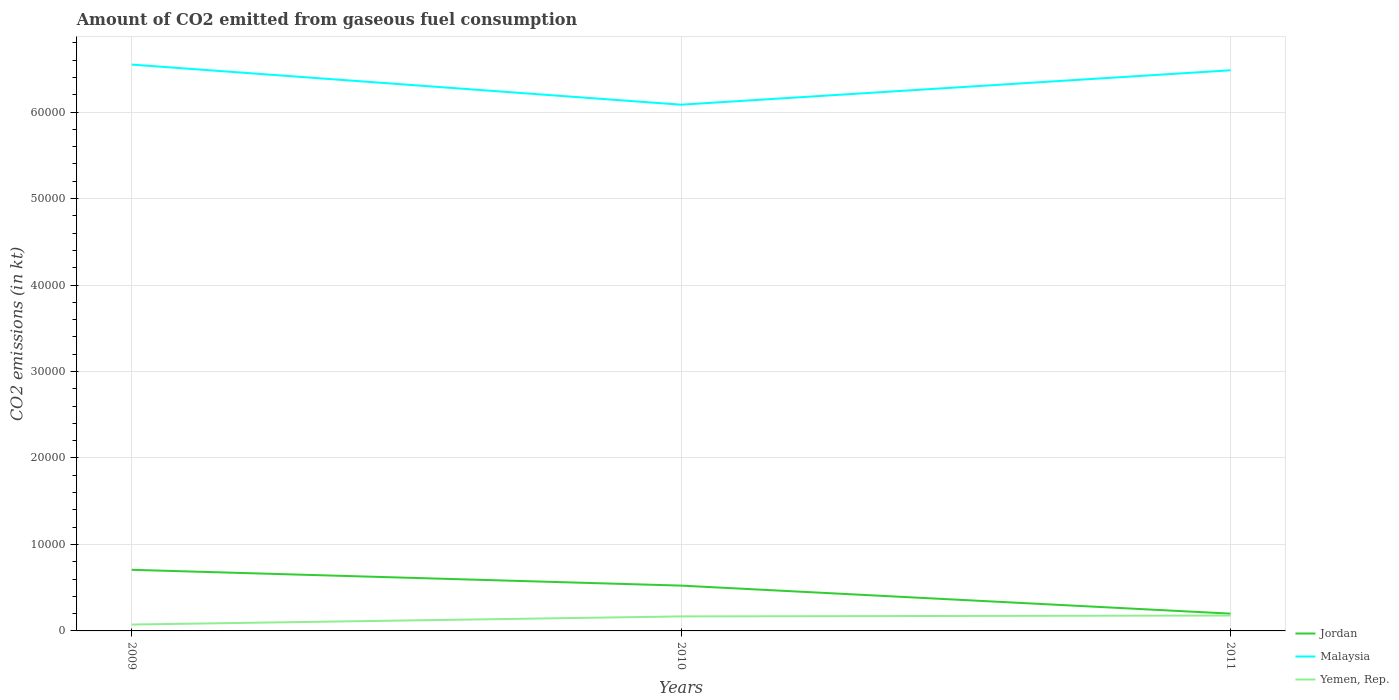Across all years, what is the maximum amount of CO2 emitted in Malaysia?
Provide a succinct answer. 6.09e+04. In which year was the amount of CO2 emitted in Yemen, Rep. maximum?
Give a very brief answer. 2009. What is the total amount of CO2 emitted in Malaysia in the graph?
Your answer should be compact. 660.06. What is the difference between the highest and the second highest amount of CO2 emitted in Malaysia?
Your response must be concise. 4638.75. What is the difference between the highest and the lowest amount of CO2 emitted in Jordan?
Keep it short and to the point. 2. How many years are there in the graph?
Your response must be concise. 3. What is the difference between two consecutive major ticks on the Y-axis?
Keep it short and to the point. 10000. Does the graph contain grids?
Offer a terse response. Yes. How are the legend labels stacked?
Keep it short and to the point. Vertical. What is the title of the graph?
Provide a short and direct response. Amount of CO2 emitted from gaseous fuel consumption. What is the label or title of the Y-axis?
Make the answer very short. CO2 emissions (in kt). What is the CO2 emissions (in kt) of Jordan in 2009?
Your answer should be compact. 7066.31. What is the CO2 emissions (in kt) of Malaysia in 2009?
Your response must be concise. 6.55e+04. What is the CO2 emissions (in kt) in Yemen, Rep. in 2009?
Your answer should be very brief. 737.07. What is the CO2 emissions (in kt) in Jordan in 2010?
Your answer should be compact. 5240.14. What is the CO2 emissions (in kt) in Malaysia in 2010?
Offer a terse response. 6.09e+04. What is the CO2 emissions (in kt) of Yemen, Rep. in 2010?
Your answer should be very brief. 1679.49. What is the CO2 emissions (in kt) in Jordan in 2011?
Keep it short and to the point. 1998.52. What is the CO2 emissions (in kt) of Malaysia in 2011?
Make the answer very short. 6.48e+04. What is the CO2 emissions (in kt) in Yemen, Rep. in 2011?
Keep it short and to the point. 1782.16. Across all years, what is the maximum CO2 emissions (in kt) in Jordan?
Give a very brief answer. 7066.31. Across all years, what is the maximum CO2 emissions (in kt) of Malaysia?
Provide a succinct answer. 6.55e+04. Across all years, what is the maximum CO2 emissions (in kt) in Yemen, Rep.?
Provide a succinct answer. 1782.16. Across all years, what is the minimum CO2 emissions (in kt) in Jordan?
Offer a terse response. 1998.52. Across all years, what is the minimum CO2 emissions (in kt) in Malaysia?
Offer a terse response. 6.09e+04. Across all years, what is the minimum CO2 emissions (in kt) of Yemen, Rep.?
Offer a very short reply. 737.07. What is the total CO2 emissions (in kt) in Jordan in the graph?
Make the answer very short. 1.43e+04. What is the total CO2 emissions (in kt) in Malaysia in the graph?
Your answer should be compact. 1.91e+05. What is the total CO2 emissions (in kt) in Yemen, Rep. in the graph?
Provide a succinct answer. 4198.72. What is the difference between the CO2 emissions (in kt) of Jordan in 2009 and that in 2010?
Your answer should be very brief. 1826.17. What is the difference between the CO2 emissions (in kt) in Malaysia in 2009 and that in 2010?
Your response must be concise. 4638.76. What is the difference between the CO2 emissions (in kt) of Yemen, Rep. in 2009 and that in 2010?
Offer a very short reply. -942.42. What is the difference between the CO2 emissions (in kt) in Jordan in 2009 and that in 2011?
Make the answer very short. 5067.79. What is the difference between the CO2 emissions (in kt) in Malaysia in 2009 and that in 2011?
Offer a very short reply. 660.06. What is the difference between the CO2 emissions (in kt) in Yemen, Rep. in 2009 and that in 2011?
Ensure brevity in your answer.  -1045.1. What is the difference between the CO2 emissions (in kt) in Jordan in 2010 and that in 2011?
Your answer should be compact. 3241.63. What is the difference between the CO2 emissions (in kt) in Malaysia in 2010 and that in 2011?
Your answer should be very brief. -3978.7. What is the difference between the CO2 emissions (in kt) in Yemen, Rep. in 2010 and that in 2011?
Provide a succinct answer. -102.68. What is the difference between the CO2 emissions (in kt) of Jordan in 2009 and the CO2 emissions (in kt) of Malaysia in 2010?
Make the answer very short. -5.38e+04. What is the difference between the CO2 emissions (in kt) in Jordan in 2009 and the CO2 emissions (in kt) in Yemen, Rep. in 2010?
Offer a very short reply. 5386.82. What is the difference between the CO2 emissions (in kt) of Malaysia in 2009 and the CO2 emissions (in kt) of Yemen, Rep. in 2010?
Your answer should be very brief. 6.38e+04. What is the difference between the CO2 emissions (in kt) of Jordan in 2009 and the CO2 emissions (in kt) of Malaysia in 2011?
Provide a succinct answer. -5.78e+04. What is the difference between the CO2 emissions (in kt) of Jordan in 2009 and the CO2 emissions (in kt) of Yemen, Rep. in 2011?
Your answer should be compact. 5284.15. What is the difference between the CO2 emissions (in kt) of Malaysia in 2009 and the CO2 emissions (in kt) of Yemen, Rep. in 2011?
Offer a very short reply. 6.37e+04. What is the difference between the CO2 emissions (in kt) of Jordan in 2010 and the CO2 emissions (in kt) of Malaysia in 2011?
Your response must be concise. -5.96e+04. What is the difference between the CO2 emissions (in kt) in Jordan in 2010 and the CO2 emissions (in kt) in Yemen, Rep. in 2011?
Keep it short and to the point. 3457.98. What is the difference between the CO2 emissions (in kt) of Malaysia in 2010 and the CO2 emissions (in kt) of Yemen, Rep. in 2011?
Provide a short and direct response. 5.91e+04. What is the average CO2 emissions (in kt) in Jordan per year?
Your response must be concise. 4768.32. What is the average CO2 emissions (in kt) of Malaysia per year?
Make the answer very short. 6.37e+04. What is the average CO2 emissions (in kt) in Yemen, Rep. per year?
Offer a very short reply. 1399.57. In the year 2009, what is the difference between the CO2 emissions (in kt) of Jordan and CO2 emissions (in kt) of Malaysia?
Offer a terse response. -5.84e+04. In the year 2009, what is the difference between the CO2 emissions (in kt) in Jordan and CO2 emissions (in kt) in Yemen, Rep.?
Give a very brief answer. 6329.24. In the year 2009, what is the difference between the CO2 emissions (in kt) in Malaysia and CO2 emissions (in kt) in Yemen, Rep.?
Provide a succinct answer. 6.48e+04. In the year 2010, what is the difference between the CO2 emissions (in kt) of Jordan and CO2 emissions (in kt) of Malaysia?
Provide a succinct answer. -5.56e+04. In the year 2010, what is the difference between the CO2 emissions (in kt) of Jordan and CO2 emissions (in kt) of Yemen, Rep.?
Make the answer very short. 3560.66. In the year 2010, what is the difference between the CO2 emissions (in kt) of Malaysia and CO2 emissions (in kt) of Yemen, Rep.?
Your response must be concise. 5.92e+04. In the year 2011, what is the difference between the CO2 emissions (in kt) in Jordan and CO2 emissions (in kt) in Malaysia?
Ensure brevity in your answer.  -6.28e+04. In the year 2011, what is the difference between the CO2 emissions (in kt) in Jordan and CO2 emissions (in kt) in Yemen, Rep.?
Give a very brief answer. 216.35. In the year 2011, what is the difference between the CO2 emissions (in kt) in Malaysia and CO2 emissions (in kt) in Yemen, Rep.?
Ensure brevity in your answer.  6.31e+04. What is the ratio of the CO2 emissions (in kt) in Jordan in 2009 to that in 2010?
Your answer should be compact. 1.35. What is the ratio of the CO2 emissions (in kt) of Malaysia in 2009 to that in 2010?
Provide a short and direct response. 1.08. What is the ratio of the CO2 emissions (in kt) of Yemen, Rep. in 2009 to that in 2010?
Offer a terse response. 0.44. What is the ratio of the CO2 emissions (in kt) of Jordan in 2009 to that in 2011?
Ensure brevity in your answer.  3.54. What is the ratio of the CO2 emissions (in kt) of Malaysia in 2009 to that in 2011?
Provide a short and direct response. 1.01. What is the ratio of the CO2 emissions (in kt) in Yemen, Rep. in 2009 to that in 2011?
Your response must be concise. 0.41. What is the ratio of the CO2 emissions (in kt) of Jordan in 2010 to that in 2011?
Offer a very short reply. 2.62. What is the ratio of the CO2 emissions (in kt) in Malaysia in 2010 to that in 2011?
Give a very brief answer. 0.94. What is the ratio of the CO2 emissions (in kt) in Yemen, Rep. in 2010 to that in 2011?
Your answer should be compact. 0.94. What is the difference between the highest and the second highest CO2 emissions (in kt) in Jordan?
Your response must be concise. 1826.17. What is the difference between the highest and the second highest CO2 emissions (in kt) of Malaysia?
Give a very brief answer. 660.06. What is the difference between the highest and the second highest CO2 emissions (in kt) in Yemen, Rep.?
Your answer should be very brief. 102.68. What is the difference between the highest and the lowest CO2 emissions (in kt) in Jordan?
Your answer should be compact. 5067.79. What is the difference between the highest and the lowest CO2 emissions (in kt) in Malaysia?
Keep it short and to the point. 4638.76. What is the difference between the highest and the lowest CO2 emissions (in kt) of Yemen, Rep.?
Give a very brief answer. 1045.1. 